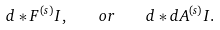Convert formula to latex. <formula><loc_0><loc_0><loc_500><loc_500>d * F ^ { ( s ) } I , \quad { o r } \quad d * d A ^ { ( s ) } I .</formula> 